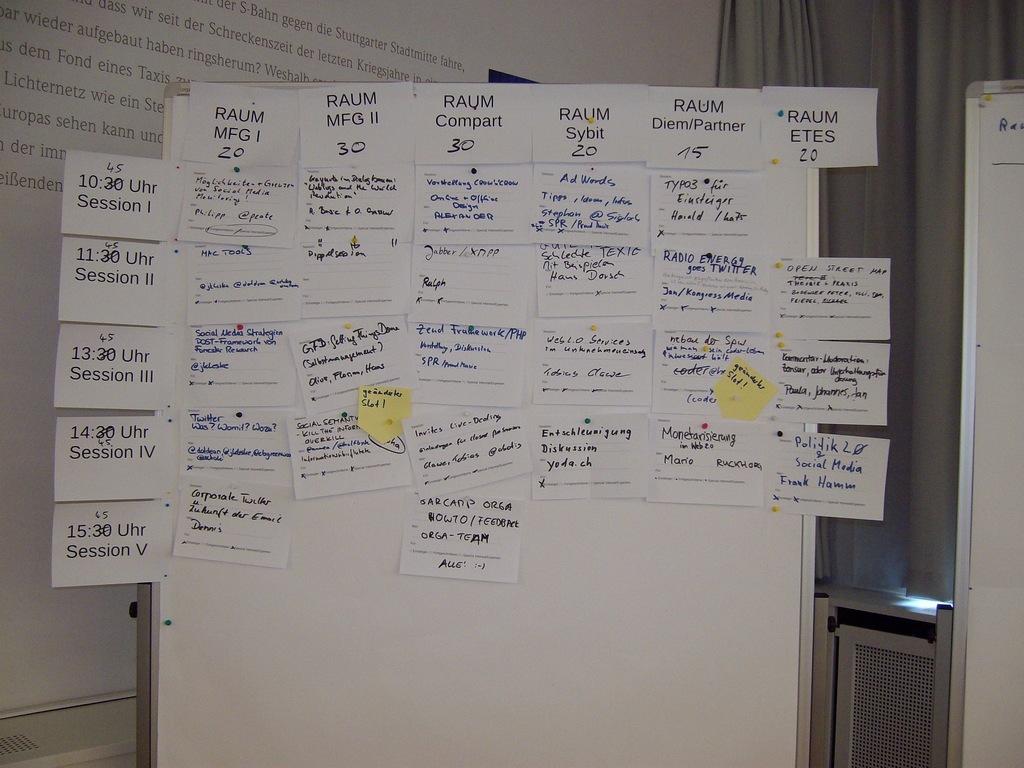What word is mentioned on all of the cards at the top of the image?
Keep it short and to the point. Raum. What time is session one?
Give a very brief answer. 10:45. 